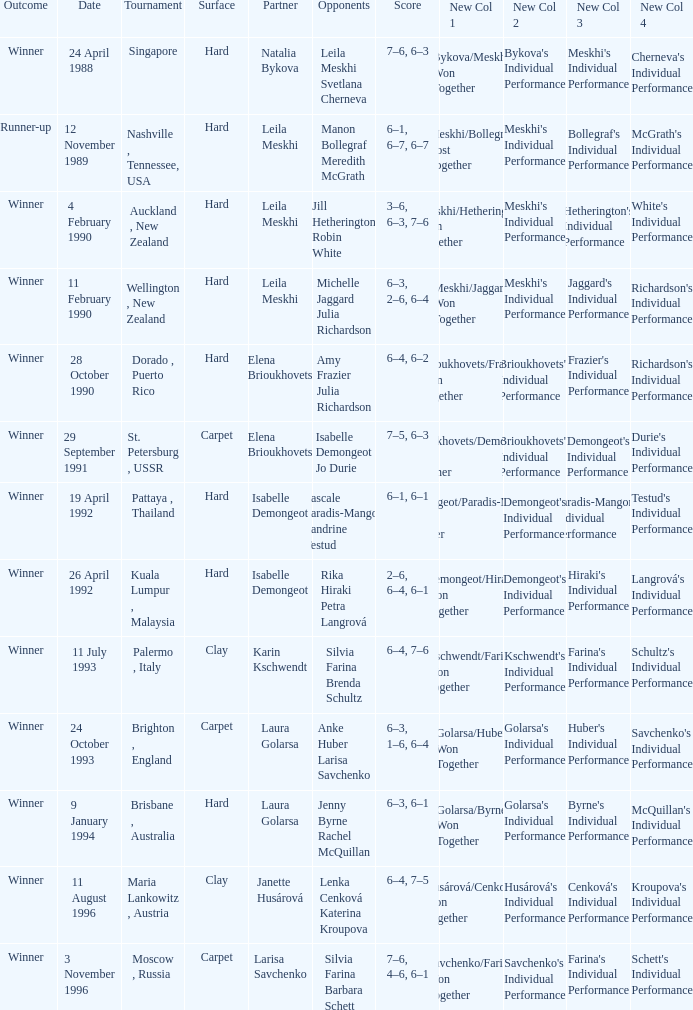Who was the Partner in a game with the Score of 6–4, 6–2 on a hard surface? Elena Brioukhovets. 